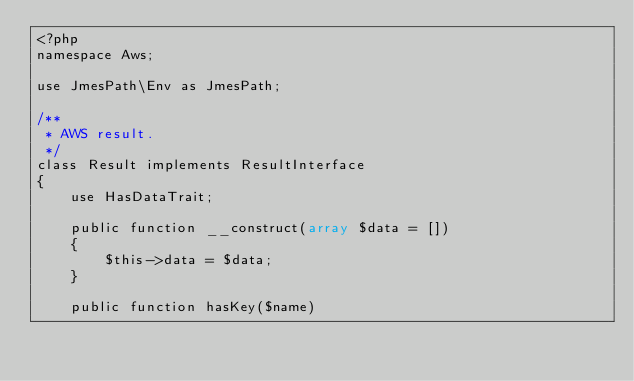<code> <loc_0><loc_0><loc_500><loc_500><_PHP_><?php
namespace Aws;

use JmesPath\Env as JmesPath;

/**
 * AWS result.
 */
class Result implements ResultInterface
{
    use HasDataTrait;

    public function __construct(array $data = [])
    {
        $this->data = $data;
    }

    public function hasKey($name)</code> 